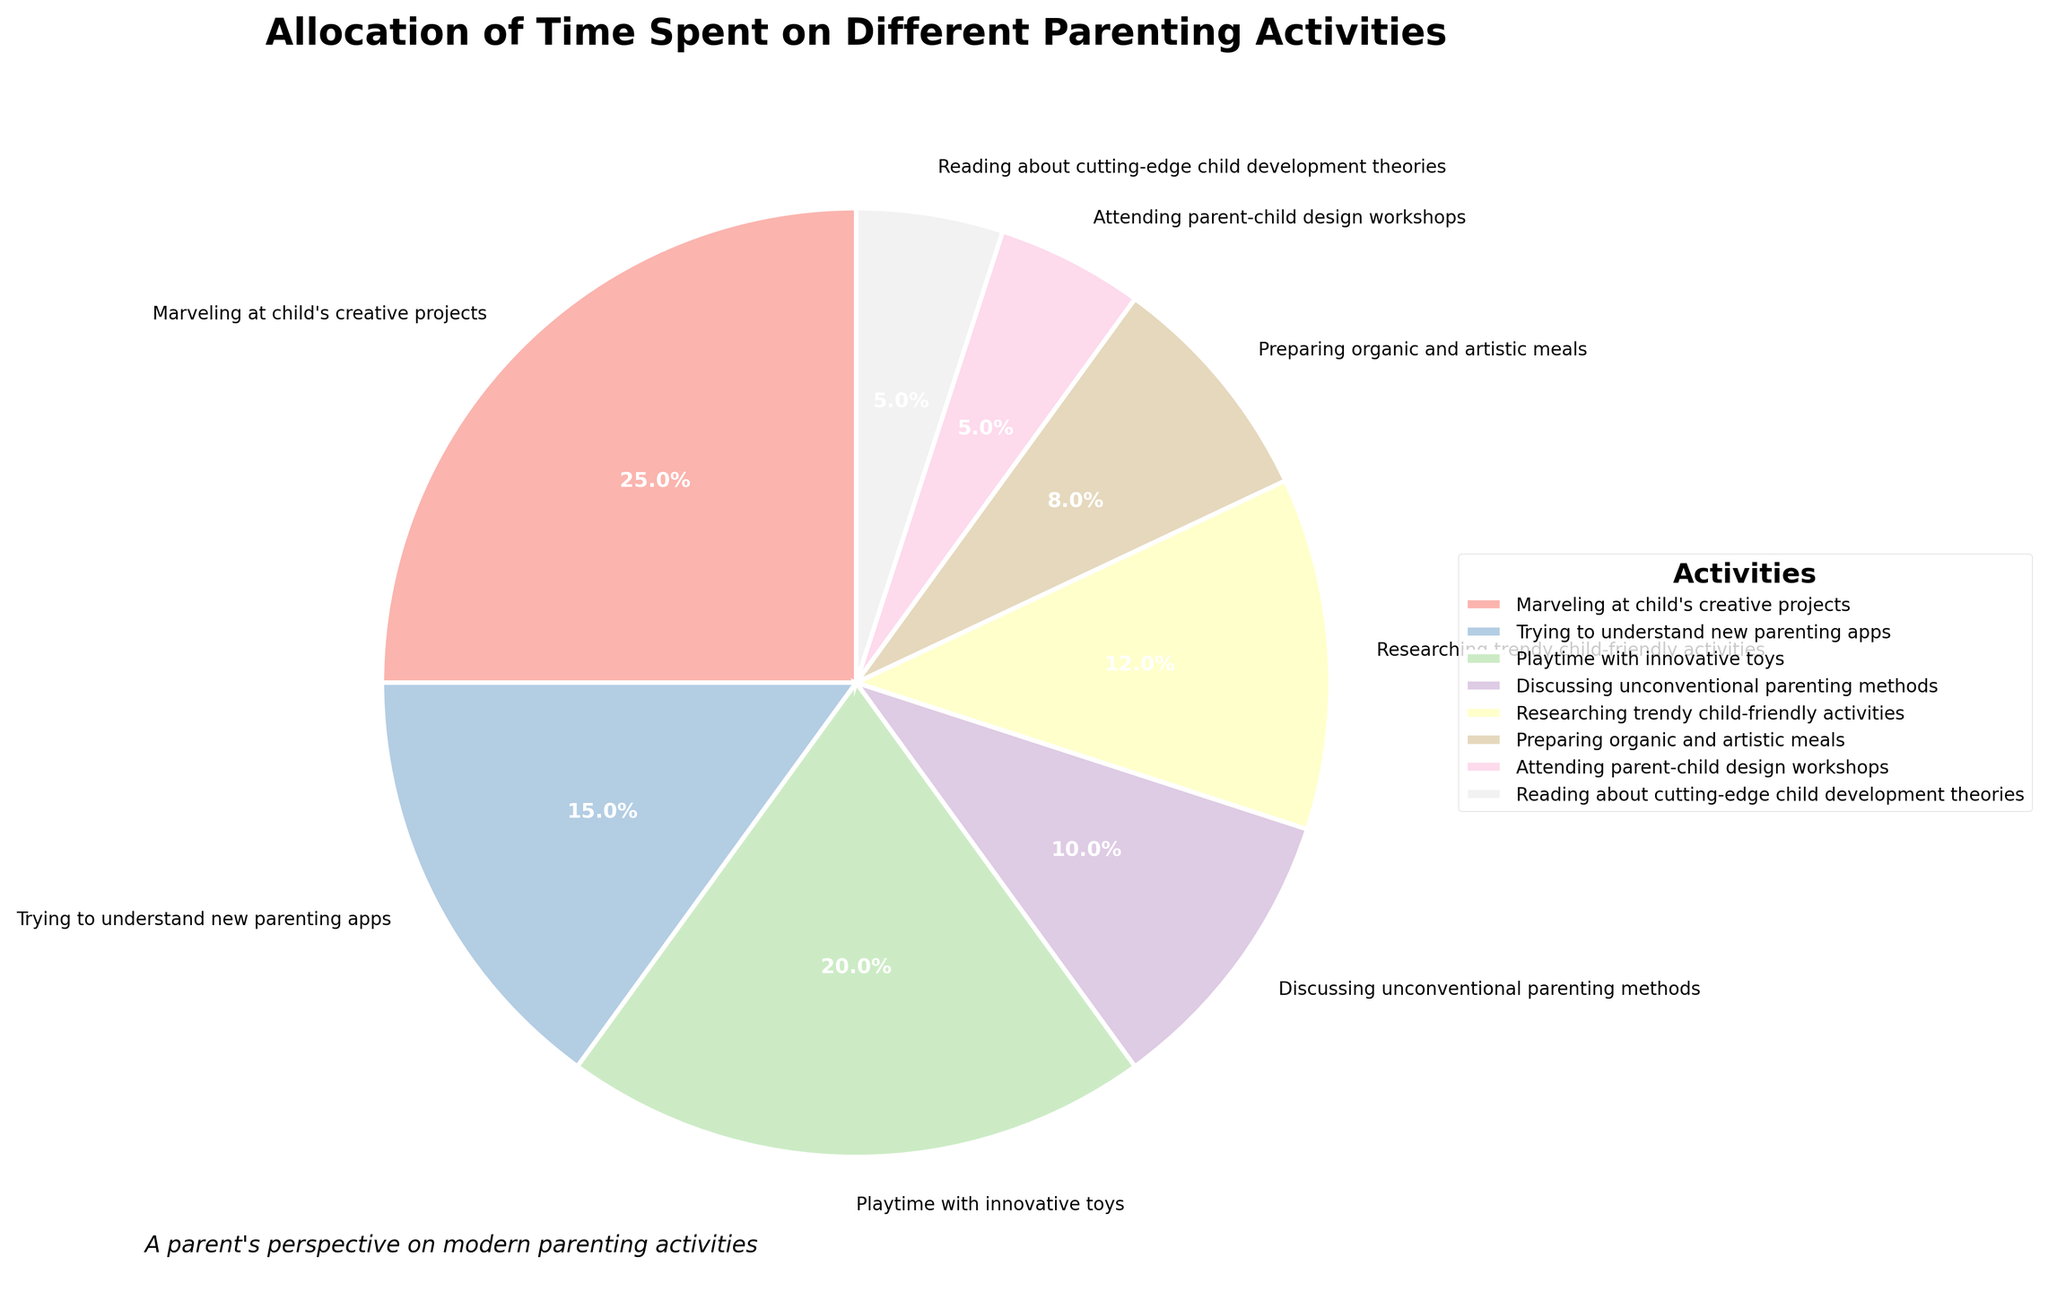What's the percentage of time spent on both "Playtime with innovative toys" and "Marveling at child's creative projects" combined? To find the combined percentage, add the percentage of time spent on "Playtime with innovative toys" (20%) to the time spent "Marveling at child's creative projects" (25%). Therefore, 20% + 25% = 45%.
Answer: 45% Which activity is allocated the least amount of time? Looking at the percentages in the pie chart, the activity with the smallest slice is attended "Attending parent-child design workshops" and "Reading about cutting-edge child development theories" both with 5%.
Answer: Attending parent-child design workshops and Researching trendy child-friendly activities Is more time spent on "Trying to understand new parenting apps" or "Discussing unconventional parenting methods"? Compare the two percentages: "Trying to understand new parenting apps" is 15%, and "Discussing unconventional parenting methods" is 10%. 15% is greater than 10%.
Answer: Trying to understand new parenting apps What's the total percentage spent on "Preparing organic and artistic meals" and attending "parent-child design workshops"? Sum the percentages for "Preparing organic and artistic meals" (8%) and "Attending parent-child design workshops" (5%). So, 8% + 5% = 13%.
Answer: 13% Which two activities have an equal percentage of time allocated? Check the pie chart and see that "Attending parent-child design workshops" and "Reading about cutting-edge child development theories" both have 5%.
Answer: Attending parent-child design workshops and Reading about cutting-edge child development theories How much more time is allocated to "Marveling at child's creative projects" compared to "Researching trendy child-friendly activities"? Subtract the percentage of "Researching trendy child-friendly activities" (12%) from the percentage of "Marveling at child's creative projects" (25%). So, 25% - 12% = 13%.
Answer: 13% more Which activity takes up 20% of the time? Find the slice of the pie chart labeled with 20%. It is "Playtime with innovative toys".
Answer: Playtime with innovative toys 